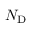Convert formula to latex. <formula><loc_0><loc_0><loc_500><loc_500>N _ { D }</formula> 